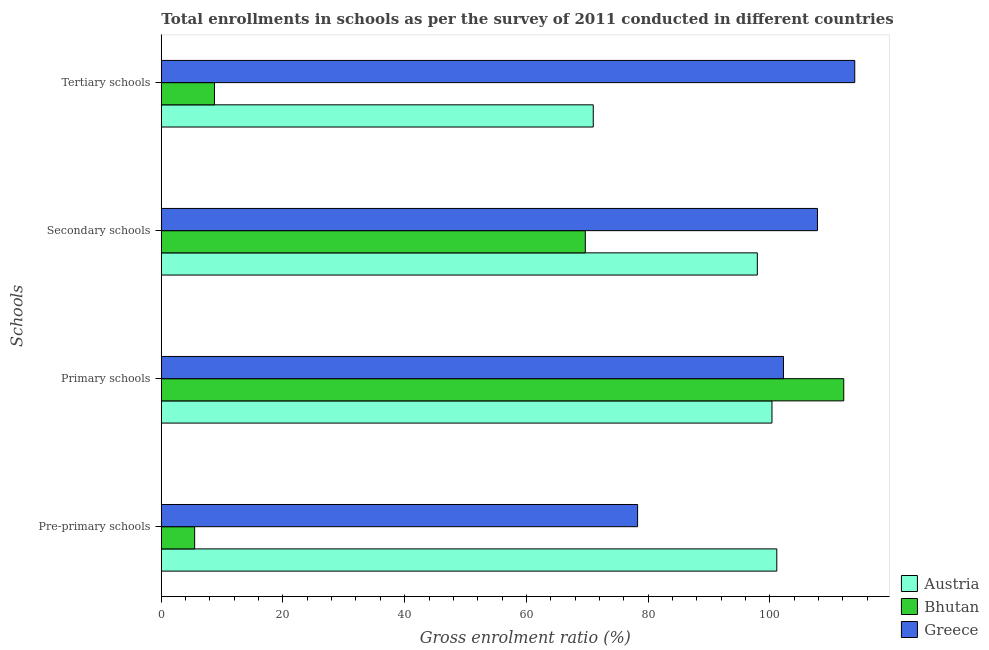How many different coloured bars are there?
Offer a terse response. 3. Are the number of bars per tick equal to the number of legend labels?
Your answer should be very brief. Yes. Are the number of bars on each tick of the Y-axis equal?
Your answer should be compact. Yes. How many bars are there on the 3rd tick from the top?
Offer a terse response. 3. How many bars are there on the 1st tick from the bottom?
Give a very brief answer. 3. What is the label of the 3rd group of bars from the top?
Give a very brief answer. Primary schools. What is the gross enrolment ratio in secondary schools in Greece?
Make the answer very short. 107.86. Across all countries, what is the maximum gross enrolment ratio in secondary schools?
Your answer should be very brief. 107.86. Across all countries, what is the minimum gross enrolment ratio in pre-primary schools?
Your response must be concise. 5.48. In which country was the gross enrolment ratio in pre-primary schools maximum?
Ensure brevity in your answer.  Austria. In which country was the gross enrolment ratio in pre-primary schools minimum?
Your answer should be compact. Bhutan. What is the total gross enrolment ratio in primary schools in the graph?
Offer a very short reply. 314.82. What is the difference between the gross enrolment ratio in tertiary schools in Bhutan and that in Austria?
Provide a succinct answer. -62.26. What is the difference between the gross enrolment ratio in primary schools in Greece and the gross enrolment ratio in secondary schools in Bhutan?
Give a very brief answer. 32.57. What is the average gross enrolment ratio in secondary schools per country?
Your answer should be very brief. 91.84. What is the difference between the gross enrolment ratio in tertiary schools and gross enrolment ratio in primary schools in Greece?
Offer a terse response. 11.72. What is the ratio of the gross enrolment ratio in tertiary schools in Austria to that in Bhutan?
Provide a succinct answer. 8.12. Is the gross enrolment ratio in primary schools in Bhutan less than that in Austria?
Make the answer very short. No. What is the difference between the highest and the second highest gross enrolment ratio in secondary schools?
Your response must be concise. 9.89. What is the difference between the highest and the lowest gross enrolment ratio in pre-primary schools?
Make the answer very short. 95.69. In how many countries, is the gross enrolment ratio in pre-primary schools greater than the average gross enrolment ratio in pre-primary schools taken over all countries?
Provide a succinct answer. 2. Is it the case that in every country, the sum of the gross enrolment ratio in pre-primary schools and gross enrolment ratio in tertiary schools is greater than the sum of gross enrolment ratio in secondary schools and gross enrolment ratio in primary schools?
Provide a short and direct response. No. What does the 3rd bar from the bottom in Secondary schools represents?
Ensure brevity in your answer.  Greece. Is it the case that in every country, the sum of the gross enrolment ratio in pre-primary schools and gross enrolment ratio in primary schools is greater than the gross enrolment ratio in secondary schools?
Make the answer very short. Yes. Are all the bars in the graph horizontal?
Your response must be concise. Yes. What is the difference between two consecutive major ticks on the X-axis?
Provide a succinct answer. 20. Does the graph contain any zero values?
Make the answer very short. No. Does the graph contain grids?
Your response must be concise. No. How many legend labels are there?
Provide a short and direct response. 3. What is the title of the graph?
Ensure brevity in your answer.  Total enrollments in schools as per the survey of 2011 conducted in different countries. Does "Cyprus" appear as one of the legend labels in the graph?
Make the answer very short. No. What is the label or title of the X-axis?
Your response must be concise. Gross enrolment ratio (%). What is the label or title of the Y-axis?
Provide a short and direct response. Schools. What is the Gross enrolment ratio (%) of Austria in Pre-primary schools?
Offer a terse response. 101.17. What is the Gross enrolment ratio (%) of Bhutan in Pre-primary schools?
Your answer should be compact. 5.48. What is the Gross enrolment ratio (%) of Greece in Pre-primary schools?
Offer a very short reply. 78.29. What is the Gross enrolment ratio (%) in Austria in Primary schools?
Your response must be concise. 100.38. What is the Gross enrolment ratio (%) of Bhutan in Primary schools?
Ensure brevity in your answer.  112.18. What is the Gross enrolment ratio (%) in Greece in Primary schools?
Offer a very short reply. 102.27. What is the Gross enrolment ratio (%) in Austria in Secondary schools?
Your answer should be very brief. 97.97. What is the Gross enrolment ratio (%) in Bhutan in Secondary schools?
Your response must be concise. 69.69. What is the Gross enrolment ratio (%) of Greece in Secondary schools?
Give a very brief answer. 107.86. What is the Gross enrolment ratio (%) in Austria in Tertiary schools?
Your answer should be very brief. 71. What is the Gross enrolment ratio (%) of Bhutan in Tertiary schools?
Give a very brief answer. 8.74. What is the Gross enrolment ratio (%) of Greece in Tertiary schools?
Offer a very short reply. 113.98. Across all Schools, what is the maximum Gross enrolment ratio (%) of Austria?
Offer a very short reply. 101.17. Across all Schools, what is the maximum Gross enrolment ratio (%) in Bhutan?
Provide a short and direct response. 112.18. Across all Schools, what is the maximum Gross enrolment ratio (%) in Greece?
Give a very brief answer. 113.98. Across all Schools, what is the minimum Gross enrolment ratio (%) in Austria?
Provide a short and direct response. 71. Across all Schools, what is the minimum Gross enrolment ratio (%) of Bhutan?
Your answer should be compact. 5.48. Across all Schools, what is the minimum Gross enrolment ratio (%) of Greece?
Provide a short and direct response. 78.29. What is the total Gross enrolment ratio (%) in Austria in the graph?
Keep it short and to the point. 370.52. What is the total Gross enrolment ratio (%) in Bhutan in the graph?
Offer a very short reply. 196.09. What is the total Gross enrolment ratio (%) of Greece in the graph?
Give a very brief answer. 402.4. What is the difference between the Gross enrolment ratio (%) of Austria in Pre-primary schools and that in Primary schools?
Ensure brevity in your answer.  0.79. What is the difference between the Gross enrolment ratio (%) of Bhutan in Pre-primary schools and that in Primary schools?
Provide a short and direct response. -106.69. What is the difference between the Gross enrolment ratio (%) of Greece in Pre-primary schools and that in Primary schools?
Your response must be concise. -23.98. What is the difference between the Gross enrolment ratio (%) in Austria in Pre-primary schools and that in Secondary schools?
Offer a very short reply. 3.2. What is the difference between the Gross enrolment ratio (%) of Bhutan in Pre-primary schools and that in Secondary schools?
Your answer should be compact. -64.21. What is the difference between the Gross enrolment ratio (%) in Greece in Pre-primary schools and that in Secondary schools?
Ensure brevity in your answer.  -29.57. What is the difference between the Gross enrolment ratio (%) of Austria in Pre-primary schools and that in Tertiary schools?
Ensure brevity in your answer.  30.17. What is the difference between the Gross enrolment ratio (%) in Bhutan in Pre-primary schools and that in Tertiary schools?
Offer a terse response. -3.26. What is the difference between the Gross enrolment ratio (%) of Greece in Pre-primary schools and that in Tertiary schools?
Offer a very short reply. -35.69. What is the difference between the Gross enrolment ratio (%) of Austria in Primary schools and that in Secondary schools?
Make the answer very short. 2.41. What is the difference between the Gross enrolment ratio (%) in Bhutan in Primary schools and that in Secondary schools?
Your answer should be very brief. 42.48. What is the difference between the Gross enrolment ratio (%) in Greece in Primary schools and that in Secondary schools?
Keep it short and to the point. -5.59. What is the difference between the Gross enrolment ratio (%) of Austria in Primary schools and that in Tertiary schools?
Ensure brevity in your answer.  29.38. What is the difference between the Gross enrolment ratio (%) of Bhutan in Primary schools and that in Tertiary schools?
Your response must be concise. 103.44. What is the difference between the Gross enrolment ratio (%) of Greece in Primary schools and that in Tertiary schools?
Ensure brevity in your answer.  -11.72. What is the difference between the Gross enrolment ratio (%) in Austria in Secondary schools and that in Tertiary schools?
Make the answer very short. 26.97. What is the difference between the Gross enrolment ratio (%) of Bhutan in Secondary schools and that in Tertiary schools?
Ensure brevity in your answer.  60.95. What is the difference between the Gross enrolment ratio (%) of Greece in Secondary schools and that in Tertiary schools?
Give a very brief answer. -6.13. What is the difference between the Gross enrolment ratio (%) in Austria in Pre-primary schools and the Gross enrolment ratio (%) in Bhutan in Primary schools?
Your answer should be very brief. -11. What is the difference between the Gross enrolment ratio (%) of Austria in Pre-primary schools and the Gross enrolment ratio (%) of Greece in Primary schools?
Ensure brevity in your answer.  -1.09. What is the difference between the Gross enrolment ratio (%) of Bhutan in Pre-primary schools and the Gross enrolment ratio (%) of Greece in Primary schools?
Your answer should be compact. -96.79. What is the difference between the Gross enrolment ratio (%) of Austria in Pre-primary schools and the Gross enrolment ratio (%) of Bhutan in Secondary schools?
Provide a short and direct response. 31.48. What is the difference between the Gross enrolment ratio (%) in Austria in Pre-primary schools and the Gross enrolment ratio (%) in Greece in Secondary schools?
Your response must be concise. -6.68. What is the difference between the Gross enrolment ratio (%) of Bhutan in Pre-primary schools and the Gross enrolment ratio (%) of Greece in Secondary schools?
Your answer should be very brief. -102.38. What is the difference between the Gross enrolment ratio (%) of Austria in Pre-primary schools and the Gross enrolment ratio (%) of Bhutan in Tertiary schools?
Your response must be concise. 92.43. What is the difference between the Gross enrolment ratio (%) of Austria in Pre-primary schools and the Gross enrolment ratio (%) of Greece in Tertiary schools?
Give a very brief answer. -12.81. What is the difference between the Gross enrolment ratio (%) of Bhutan in Pre-primary schools and the Gross enrolment ratio (%) of Greece in Tertiary schools?
Ensure brevity in your answer.  -108.5. What is the difference between the Gross enrolment ratio (%) of Austria in Primary schools and the Gross enrolment ratio (%) of Bhutan in Secondary schools?
Offer a very short reply. 30.68. What is the difference between the Gross enrolment ratio (%) in Austria in Primary schools and the Gross enrolment ratio (%) in Greece in Secondary schools?
Give a very brief answer. -7.48. What is the difference between the Gross enrolment ratio (%) of Bhutan in Primary schools and the Gross enrolment ratio (%) of Greece in Secondary schools?
Make the answer very short. 4.32. What is the difference between the Gross enrolment ratio (%) of Austria in Primary schools and the Gross enrolment ratio (%) of Bhutan in Tertiary schools?
Your response must be concise. 91.64. What is the difference between the Gross enrolment ratio (%) of Austria in Primary schools and the Gross enrolment ratio (%) of Greece in Tertiary schools?
Provide a succinct answer. -13.61. What is the difference between the Gross enrolment ratio (%) in Bhutan in Primary schools and the Gross enrolment ratio (%) in Greece in Tertiary schools?
Offer a very short reply. -1.81. What is the difference between the Gross enrolment ratio (%) of Austria in Secondary schools and the Gross enrolment ratio (%) of Bhutan in Tertiary schools?
Provide a short and direct response. 89.23. What is the difference between the Gross enrolment ratio (%) of Austria in Secondary schools and the Gross enrolment ratio (%) of Greece in Tertiary schools?
Provide a succinct answer. -16.01. What is the difference between the Gross enrolment ratio (%) in Bhutan in Secondary schools and the Gross enrolment ratio (%) in Greece in Tertiary schools?
Your answer should be very brief. -44.29. What is the average Gross enrolment ratio (%) of Austria per Schools?
Your response must be concise. 92.63. What is the average Gross enrolment ratio (%) in Bhutan per Schools?
Offer a terse response. 49.02. What is the average Gross enrolment ratio (%) in Greece per Schools?
Provide a short and direct response. 100.6. What is the difference between the Gross enrolment ratio (%) of Austria and Gross enrolment ratio (%) of Bhutan in Pre-primary schools?
Make the answer very short. 95.69. What is the difference between the Gross enrolment ratio (%) of Austria and Gross enrolment ratio (%) of Greece in Pre-primary schools?
Ensure brevity in your answer.  22.88. What is the difference between the Gross enrolment ratio (%) in Bhutan and Gross enrolment ratio (%) in Greece in Pre-primary schools?
Keep it short and to the point. -72.81. What is the difference between the Gross enrolment ratio (%) in Austria and Gross enrolment ratio (%) in Bhutan in Primary schools?
Make the answer very short. -11.8. What is the difference between the Gross enrolment ratio (%) in Austria and Gross enrolment ratio (%) in Greece in Primary schools?
Your response must be concise. -1.89. What is the difference between the Gross enrolment ratio (%) in Bhutan and Gross enrolment ratio (%) in Greece in Primary schools?
Your answer should be compact. 9.91. What is the difference between the Gross enrolment ratio (%) of Austria and Gross enrolment ratio (%) of Bhutan in Secondary schools?
Keep it short and to the point. 28.28. What is the difference between the Gross enrolment ratio (%) of Austria and Gross enrolment ratio (%) of Greece in Secondary schools?
Your answer should be compact. -9.89. What is the difference between the Gross enrolment ratio (%) in Bhutan and Gross enrolment ratio (%) in Greece in Secondary schools?
Your answer should be compact. -38.16. What is the difference between the Gross enrolment ratio (%) of Austria and Gross enrolment ratio (%) of Bhutan in Tertiary schools?
Offer a terse response. 62.26. What is the difference between the Gross enrolment ratio (%) of Austria and Gross enrolment ratio (%) of Greece in Tertiary schools?
Keep it short and to the point. -42.98. What is the difference between the Gross enrolment ratio (%) of Bhutan and Gross enrolment ratio (%) of Greece in Tertiary schools?
Provide a short and direct response. -105.24. What is the ratio of the Gross enrolment ratio (%) of Austria in Pre-primary schools to that in Primary schools?
Give a very brief answer. 1.01. What is the ratio of the Gross enrolment ratio (%) in Bhutan in Pre-primary schools to that in Primary schools?
Provide a succinct answer. 0.05. What is the ratio of the Gross enrolment ratio (%) of Greece in Pre-primary schools to that in Primary schools?
Ensure brevity in your answer.  0.77. What is the ratio of the Gross enrolment ratio (%) of Austria in Pre-primary schools to that in Secondary schools?
Offer a very short reply. 1.03. What is the ratio of the Gross enrolment ratio (%) of Bhutan in Pre-primary schools to that in Secondary schools?
Your answer should be compact. 0.08. What is the ratio of the Gross enrolment ratio (%) of Greece in Pre-primary schools to that in Secondary schools?
Ensure brevity in your answer.  0.73. What is the ratio of the Gross enrolment ratio (%) of Austria in Pre-primary schools to that in Tertiary schools?
Your response must be concise. 1.43. What is the ratio of the Gross enrolment ratio (%) of Bhutan in Pre-primary schools to that in Tertiary schools?
Provide a succinct answer. 0.63. What is the ratio of the Gross enrolment ratio (%) in Greece in Pre-primary schools to that in Tertiary schools?
Ensure brevity in your answer.  0.69. What is the ratio of the Gross enrolment ratio (%) in Austria in Primary schools to that in Secondary schools?
Ensure brevity in your answer.  1.02. What is the ratio of the Gross enrolment ratio (%) of Bhutan in Primary schools to that in Secondary schools?
Give a very brief answer. 1.61. What is the ratio of the Gross enrolment ratio (%) of Greece in Primary schools to that in Secondary schools?
Your answer should be compact. 0.95. What is the ratio of the Gross enrolment ratio (%) of Austria in Primary schools to that in Tertiary schools?
Offer a very short reply. 1.41. What is the ratio of the Gross enrolment ratio (%) of Bhutan in Primary schools to that in Tertiary schools?
Your answer should be compact. 12.83. What is the ratio of the Gross enrolment ratio (%) of Greece in Primary schools to that in Tertiary schools?
Your answer should be very brief. 0.9. What is the ratio of the Gross enrolment ratio (%) of Austria in Secondary schools to that in Tertiary schools?
Make the answer very short. 1.38. What is the ratio of the Gross enrolment ratio (%) in Bhutan in Secondary schools to that in Tertiary schools?
Make the answer very short. 7.97. What is the ratio of the Gross enrolment ratio (%) of Greece in Secondary schools to that in Tertiary schools?
Give a very brief answer. 0.95. What is the difference between the highest and the second highest Gross enrolment ratio (%) in Austria?
Your response must be concise. 0.79. What is the difference between the highest and the second highest Gross enrolment ratio (%) in Bhutan?
Keep it short and to the point. 42.48. What is the difference between the highest and the second highest Gross enrolment ratio (%) in Greece?
Make the answer very short. 6.13. What is the difference between the highest and the lowest Gross enrolment ratio (%) in Austria?
Keep it short and to the point. 30.17. What is the difference between the highest and the lowest Gross enrolment ratio (%) of Bhutan?
Offer a very short reply. 106.69. What is the difference between the highest and the lowest Gross enrolment ratio (%) in Greece?
Ensure brevity in your answer.  35.69. 